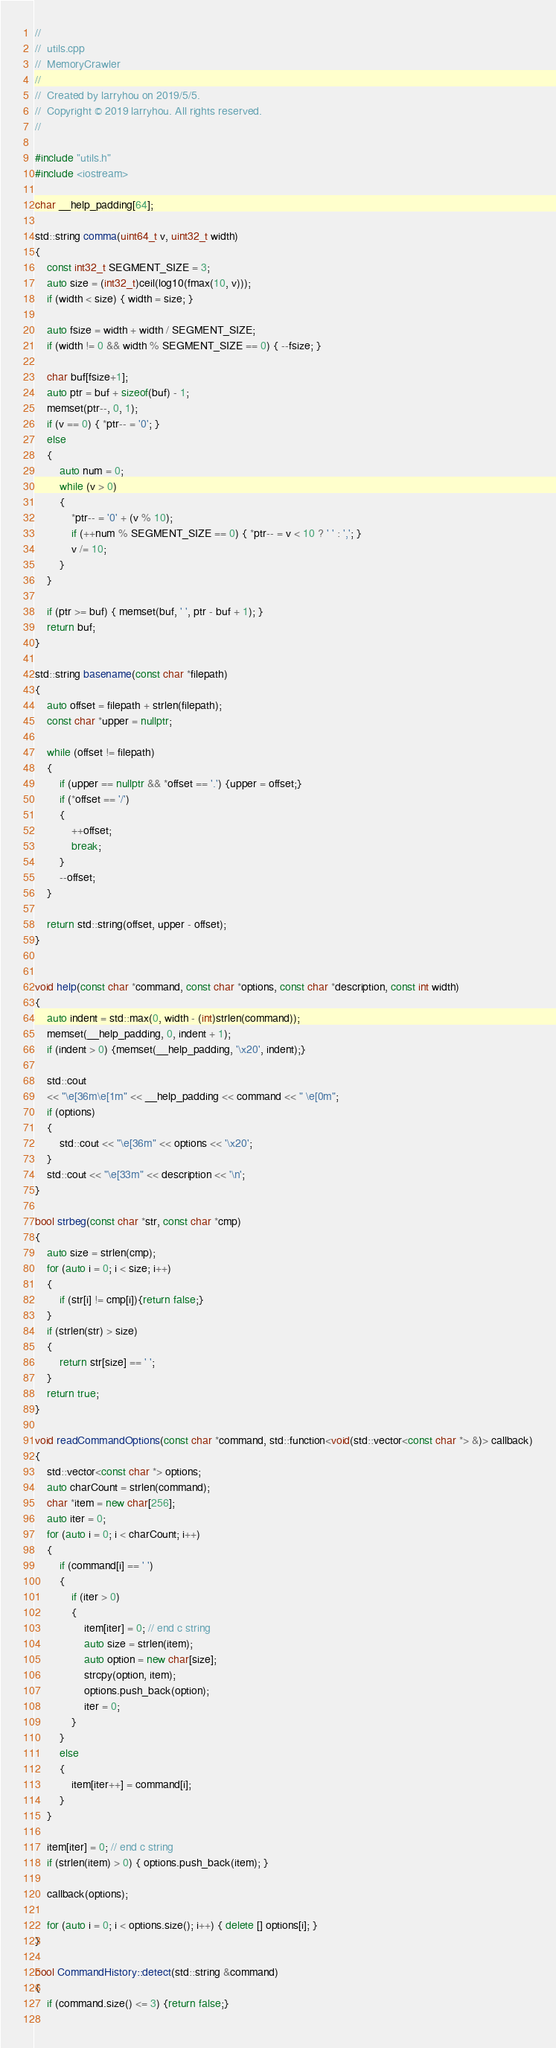<code> <loc_0><loc_0><loc_500><loc_500><_C++_>//
//  utils.cpp
//  MemoryCrawler
//
//  Created by larryhou on 2019/5/5.
//  Copyright © 2019 larryhou. All rights reserved.
//

#include "utils.h"
#include <iostream>

char __help_padding[64];

std::string comma(uint64_t v, uint32_t width)
{
    const int32_t SEGMENT_SIZE = 3;
    auto size = (int32_t)ceil(log10(fmax(10, v)));
    if (width < size) { width = size; }
    
    auto fsize = width + width / SEGMENT_SIZE;
    if (width != 0 && width % SEGMENT_SIZE == 0) { --fsize; }
    
    char buf[fsize+1];
    auto ptr = buf + sizeof(buf) - 1;
    memset(ptr--, 0, 1);
    if (v == 0) { *ptr-- = '0'; }
    else
    {
        auto num = 0;
        while (v > 0)
        {
            *ptr-- = '0' + (v % 10);
            if (++num % SEGMENT_SIZE == 0) { *ptr-- = v < 10 ? ' ' : ','; }
            v /= 10;
        }
    }
    
    if (ptr >= buf) { memset(buf, ' ', ptr - buf + 1); }
    return buf;
}

std::string basename(const char *filepath)
{
    auto offset = filepath + strlen(filepath);
    const char *upper = nullptr;
    
    while (offset != filepath)
    {
        if (upper == nullptr && *offset == '.') {upper = offset;}
        if (*offset == '/')
        {
            ++offset;
            break;
        }
        --offset;
    }
    
    return std::string(offset, upper - offset);
}


void help(const char *command, const char *options, const char *description, const int width)
{
    auto indent = std::max(0, width - (int)strlen(command));
    memset(__help_padding, 0, indent + 1);
    if (indent > 0) {memset(__help_padding, '\x20', indent);}
    
    std::cout
    << "\e[36m\e[1m" << __help_padding << command << " \e[0m";
    if (options)
    {
        std::cout << "\e[36m" << options << '\x20';
    }
    std::cout << "\e[33m" << description << '\n';
}

bool strbeg(const char *str, const char *cmp)
{
    auto size = strlen(cmp);
    for (auto i = 0; i < size; i++)
    {
        if (str[i] != cmp[i]){return false;}
    }
    if (strlen(str) > size)
    {
        return str[size] == ' ';
    }
    return true;
}

void readCommandOptions(const char *command, std::function<void(std::vector<const char *> &)> callback)
{
    std::vector<const char *> options;
    auto charCount = strlen(command);
    char *item = new char[256];
    auto iter = 0;
    for (auto i = 0; i < charCount; i++)
    {
        if (command[i] == ' ')
        {
            if (iter > 0)
            {
                item[iter] = 0; // end c string
                auto size = strlen(item);
                auto option = new char[size];
                strcpy(option, item);
                options.push_back(option);
                iter = 0;
            }
        }
        else
        {
            item[iter++] = command[i];
        }
    }
    
    item[iter] = 0; // end c string
    if (strlen(item) > 0) { options.push_back(item); }
    
    callback(options);
    
    for (auto i = 0; i < options.size(); i++) { delete [] options[i]; }
}

bool CommandHistory::detect(std::string &command)
{
    if (command.size() <= 3) {return false;}
    </code> 